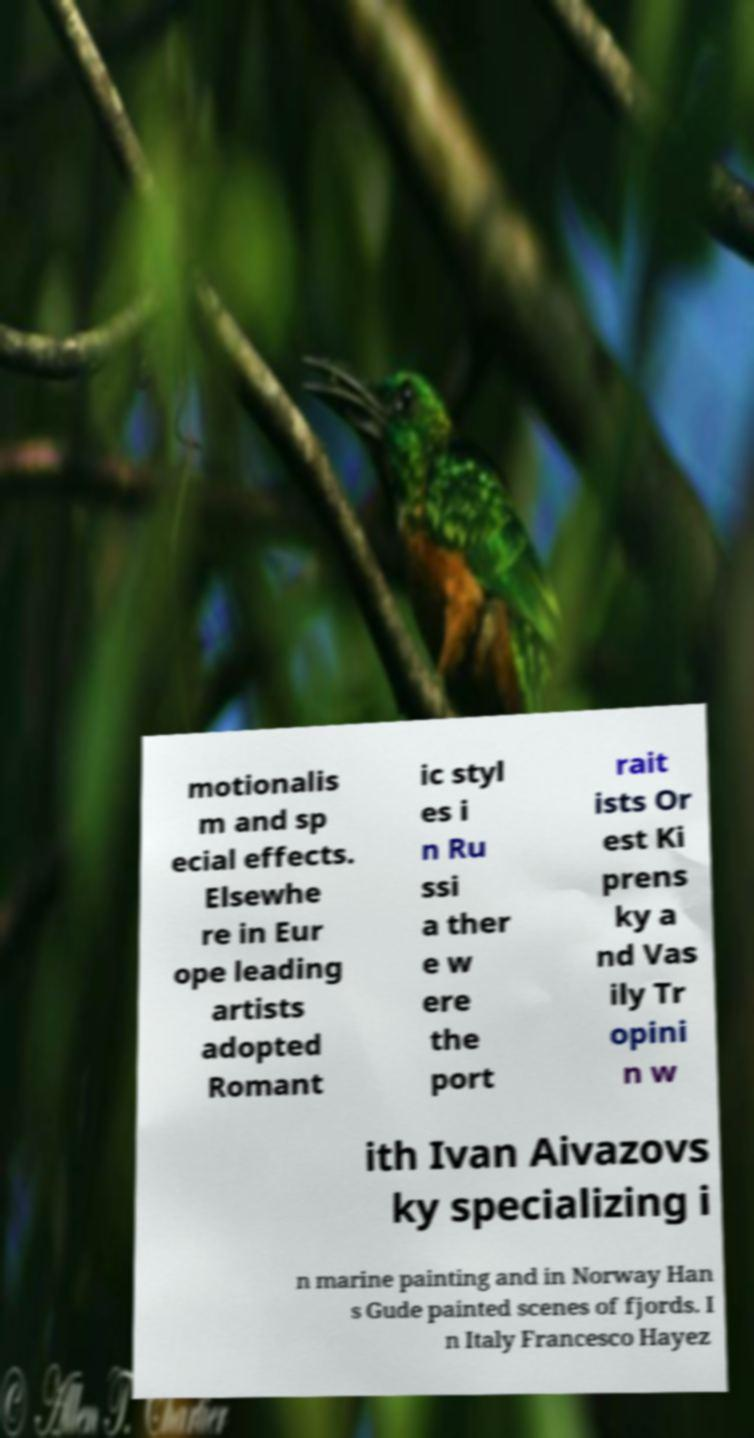Could you extract and type out the text from this image? motionalis m and sp ecial effects. Elsewhe re in Eur ope leading artists adopted Romant ic styl es i n Ru ssi a ther e w ere the port rait ists Or est Ki prens ky a nd Vas ily Tr opini n w ith Ivan Aivazovs ky specializing i n marine painting and in Norway Han s Gude painted scenes of fjords. I n Italy Francesco Hayez 